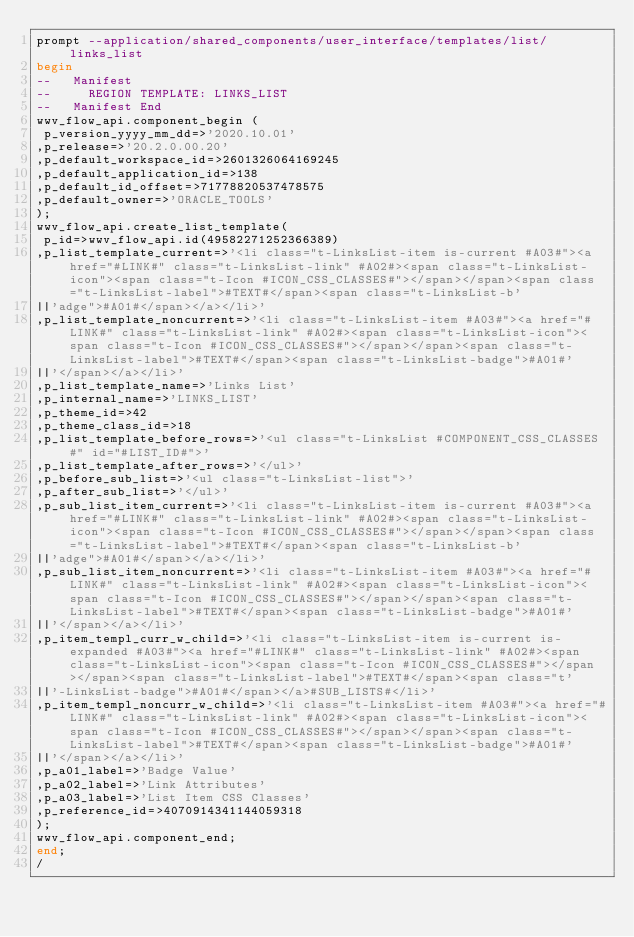Convert code to text. <code><loc_0><loc_0><loc_500><loc_500><_SQL_>prompt --application/shared_components/user_interface/templates/list/links_list
begin
--   Manifest
--     REGION TEMPLATE: LINKS_LIST
--   Manifest End
wwv_flow_api.component_begin (
 p_version_yyyy_mm_dd=>'2020.10.01'
,p_release=>'20.2.0.00.20'
,p_default_workspace_id=>2601326064169245
,p_default_application_id=>138
,p_default_id_offset=>71778820537478575
,p_default_owner=>'ORACLE_TOOLS'
);
wwv_flow_api.create_list_template(
 p_id=>wwv_flow_api.id(49582271252366389)
,p_list_template_current=>'<li class="t-LinksList-item is-current #A03#"><a href="#LINK#" class="t-LinksList-link" #A02#><span class="t-LinksList-icon"><span class="t-Icon #ICON_CSS_CLASSES#"></span></span><span class="t-LinksList-label">#TEXT#</span><span class="t-LinksList-b'
||'adge">#A01#</span></a></li>'
,p_list_template_noncurrent=>'<li class="t-LinksList-item #A03#"><a href="#LINK#" class="t-LinksList-link" #A02#><span class="t-LinksList-icon"><span class="t-Icon #ICON_CSS_CLASSES#"></span></span><span class="t-LinksList-label">#TEXT#</span><span class="t-LinksList-badge">#A01#'
||'</span></a></li>'
,p_list_template_name=>'Links List'
,p_internal_name=>'LINKS_LIST'
,p_theme_id=>42
,p_theme_class_id=>18
,p_list_template_before_rows=>'<ul class="t-LinksList #COMPONENT_CSS_CLASSES#" id="#LIST_ID#">'
,p_list_template_after_rows=>'</ul>'
,p_before_sub_list=>'<ul class="t-LinksList-list">'
,p_after_sub_list=>'</ul>'
,p_sub_list_item_current=>'<li class="t-LinksList-item is-current #A03#"><a href="#LINK#" class="t-LinksList-link" #A02#><span class="t-LinksList-icon"><span class="t-Icon #ICON_CSS_CLASSES#"></span></span><span class="t-LinksList-label">#TEXT#</span><span class="t-LinksList-b'
||'adge">#A01#</span></a></li>'
,p_sub_list_item_noncurrent=>'<li class="t-LinksList-item #A03#"><a href="#LINK#" class="t-LinksList-link" #A02#><span class="t-LinksList-icon"><span class="t-Icon #ICON_CSS_CLASSES#"></span></span><span class="t-LinksList-label">#TEXT#</span><span class="t-LinksList-badge">#A01#'
||'</span></a></li>'
,p_item_templ_curr_w_child=>'<li class="t-LinksList-item is-current is-expanded #A03#"><a href="#LINK#" class="t-LinksList-link" #A02#><span class="t-LinksList-icon"><span class="t-Icon #ICON_CSS_CLASSES#"></span></span><span class="t-LinksList-label">#TEXT#</span><span class="t'
||'-LinksList-badge">#A01#</span></a>#SUB_LISTS#</li>'
,p_item_templ_noncurr_w_child=>'<li class="t-LinksList-item #A03#"><a href="#LINK#" class="t-LinksList-link" #A02#><span class="t-LinksList-icon"><span class="t-Icon #ICON_CSS_CLASSES#"></span></span><span class="t-LinksList-label">#TEXT#</span><span class="t-LinksList-badge">#A01#'
||'</span></a></li>'
,p_a01_label=>'Badge Value'
,p_a02_label=>'Link Attributes'
,p_a03_label=>'List Item CSS Classes'
,p_reference_id=>4070914341144059318
);
wwv_flow_api.component_end;
end;
/
</code> 